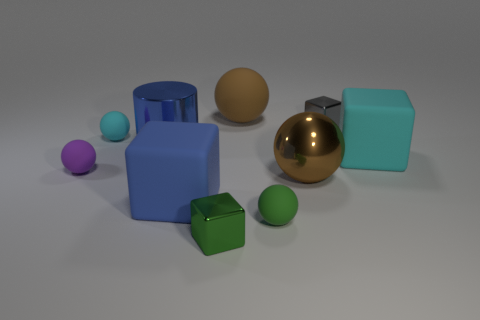Is there a pattern in how the objects are arranged? The objects are arranged without a distinct pattern but placed with some spacing between them. They are grouped loosely by shape, with the spheres close to each other on one side and the cube-shaped objects on another, suggesting an informal organization rather than a strict pattern. 